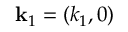<formula> <loc_0><loc_0><loc_500><loc_500>k _ { 1 } = ( k _ { 1 } , 0 )</formula> 